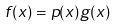Convert formula to latex. <formula><loc_0><loc_0><loc_500><loc_500>f ( x ) = p ( x ) g ( x )</formula> 